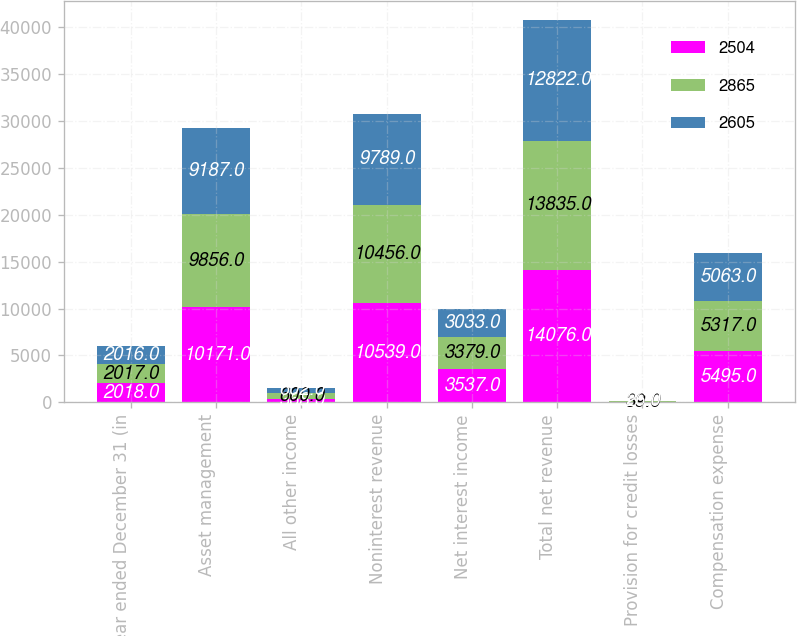Convert chart to OTSL. <chart><loc_0><loc_0><loc_500><loc_500><stacked_bar_chart><ecel><fcel>Year ended December 31 (in<fcel>Asset management<fcel>All other income<fcel>Noninterest revenue<fcel>Net interest income<fcel>Total net revenue<fcel>Provision for credit losses<fcel>Compensation expense<nl><fcel>2504<fcel>2018<fcel>10171<fcel>368<fcel>10539<fcel>3537<fcel>14076<fcel>53<fcel>5495<nl><fcel>2865<fcel>2017<fcel>9856<fcel>600<fcel>10456<fcel>3379<fcel>13835<fcel>39<fcel>5317<nl><fcel>2605<fcel>2016<fcel>9187<fcel>602<fcel>9789<fcel>3033<fcel>12822<fcel>26<fcel>5063<nl></chart> 